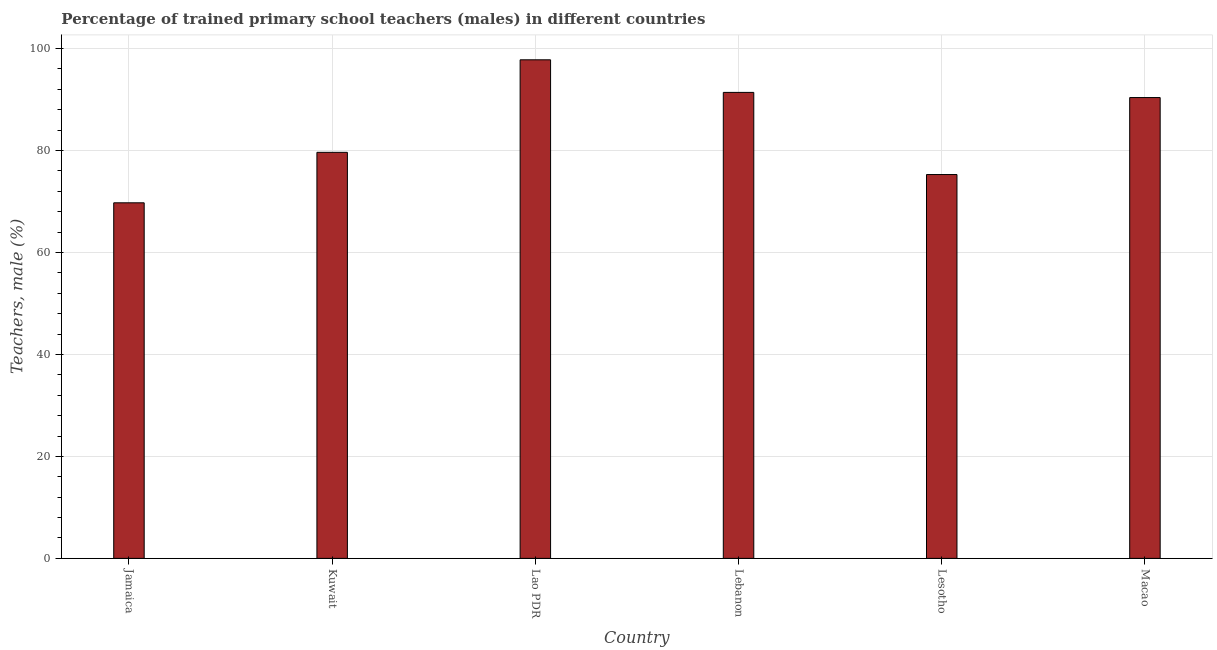Does the graph contain any zero values?
Your answer should be very brief. No. Does the graph contain grids?
Your answer should be compact. Yes. What is the title of the graph?
Keep it short and to the point. Percentage of trained primary school teachers (males) in different countries. What is the label or title of the X-axis?
Keep it short and to the point. Country. What is the label or title of the Y-axis?
Your response must be concise. Teachers, male (%). What is the percentage of trained male teachers in Lesotho?
Make the answer very short. 75.27. Across all countries, what is the maximum percentage of trained male teachers?
Your response must be concise. 97.77. Across all countries, what is the minimum percentage of trained male teachers?
Your response must be concise. 69.73. In which country was the percentage of trained male teachers maximum?
Your answer should be compact. Lao PDR. In which country was the percentage of trained male teachers minimum?
Ensure brevity in your answer.  Jamaica. What is the sum of the percentage of trained male teachers?
Your answer should be compact. 504.14. What is the difference between the percentage of trained male teachers in Lebanon and Lesotho?
Your answer should be compact. 16.11. What is the average percentage of trained male teachers per country?
Your answer should be very brief. 84.02. What is the median percentage of trained male teachers?
Give a very brief answer. 85. In how many countries, is the percentage of trained male teachers greater than 88 %?
Keep it short and to the point. 3. What is the ratio of the percentage of trained male teachers in Lebanon to that in Lesotho?
Your answer should be compact. 1.21. Is the difference between the percentage of trained male teachers in Jamaica and Kuwait greater than the difference between any two countries?
Your answer should be very brief. No. What is the difference between the highest and the second highest percentage of trained male teachers?
Offer a terse response. 6.39. What is the difference between the highest and the lowest percentage of trained male teachers?
Your response must be concise. 28.04. How many bars are there?
Your answer should be very brief. 6. Are all the bars in the graph horizontal?
Give a very brief answer. No. How many countries are there in the graph?
Make the answer very short. 6. What is the difference between two consecutive major ticks on the Y-axis?
Provide a short and direct response. 20. Are the values on the major ticks of Y-axis written in scientific E-notation?
Offer a very short reply. No. What is the Teachers, male (%) in Jamaica?
Offer a terse response. 69.73. What is the Teachers, male (%) of Kuwait?
Your response must be concise. 79.63. What is the Teachers, male (%) in Lao PDR?
Your response must be concise. 97.77. What is the Teachers, male (%) of Lebanon?
Ensure brevity in your answer.  91.38. What is the Teachers, male (%) in Lesotho?
Offer a very short reply. 75.27. What is the Teachers, male (%) in Macao?
Provide a short and direct response. 90.37. What is the difference between the Teachers, male (%) in Jamaica and Kuwait?
Give a very brief answer. -9.9. What is the difference between the Teachers, male (%) in Jamaica and Lao PDR?
Your answer should be very brief. -28.04. What is the difference between the Teachers, male (%) in Jamaica and Lebanon?
Provide a short and direct response. -21.65. What is the difference between the Teachers, male (%) in Jamaica and Lesotho?
Keep it short and to the point. -5.54. What is the difference between the Teachers, male (%) in Jamaica and Macao?
Make the answer very short. -20.64. What is the difference between the Teachers, male (%) in Kuwait and Lao PDR?
Ensure brevity in your answer.  -18.14. What is the difference between the Teachers, male (%) in Kuwait and Lebanon?
Give a very brief answer. -11.75. What is the difference between the Teachers, male (%) in Kuwait and Lesotho?
Offer a very short reply. 4.35. What is the difference between the Teachers, male (%) in Kuwait and Macao?
Keep it short and to the point. -10.74. What is the difference between the Teachers, male (%) in Lao PDR and Lebanon?
Your response must be concise. 6.39. What is the difference between the Teachers, male (%) in Lao PDR and Lesotho?
Your answer should be compact. 22.5. What is the difference between the Teachers, male (%) in Lao PDR and Macao?
Make the answer very short. 7.4. What is the difference between the Teachers, male (%) in Lebanon and Lesotho?
Make the answer very short. 16.11. What is the difference between the Teachers, male (%) in Lebanon and Macao?
Your answer should be compact. 1.01. What is the difference between the Teachers, male (%) in Lesotho and Macao?
Your answer should be compact. -15.1. What is the ratio of the Teachers, male (%) in Jamaica to that in Kuwait?
Your answer should be compact. 0.88. What is the ratio of the Teachers, male (%) in Jamaica to that in Lao PDR?
Ensure brevity in your answer.  0.71. What is the ratio of the Teachers, male (%) in Jamaica to that in Lebanon?
Offer a very short reply. 0.76. What is the ratio of the Teachers, male (%) in Jamaica to that in Lesotho?
Provide a short and direct response. 0.93. What is the ratio of the Teachers, male (%) in Jamaica to that in Macao?
Provide a short and direct response. 0.77. What is the ratio of the Teachers, male (%) in Kuwait to that in Lao PDR?
Ensure brevity in your answer.  0.81. What is the ratio of the Teachers, male (%) in Kuwait to that in Lebanon?
Make the answer very short. 0.87. What is the ratio of the Teachers, male (%) in Kuwait to that in Lesotho?
Your response must be concise. 1.06. What is the ratio of the Teachers, male (%) in Kuwait to that in Macao?
Provide a short and direct response. 0.88. What is the ratio of the Teachers, male (%) in Lao PDR to that in Lebanon?
Keep it short and to the point. 1.07. What is the ratio of the Teachers, male (%) in Lao PDR to that in Lesotho?
Your response must be concise. 1.3. What is the ratio of the Teachers, male (%) in Lao PDR to that in Macao?
Make the answer very short. 1.08. What is the ratio of the Teachers, male (%) in Lebanon to that in Lesotho?
Provide a short and direct response. 1.21. What is the ratio of the Teachers, male (%) in Lebanon to that in Macao?
Offer a very short reply. 1.01. What is the ratio of the Teachers, male (%) in Lesotho to that in Macao?
Your response must be concise. 0.83. 